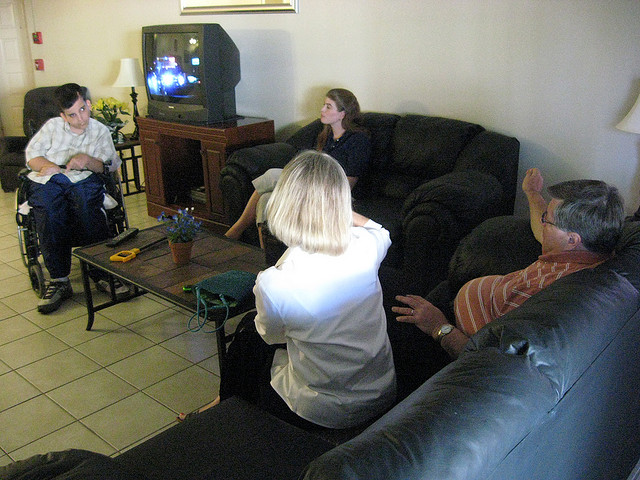<image>What is the couple celebrating? It is ambiguous what the couple is celebrating or if they are celebrating at all. What is the couple celebrating? I am not sure what the couple is celebrating. It can be seen as celebrating 'anniversary' but I can't tell for sure. 